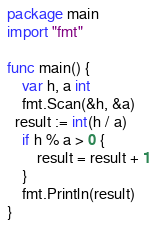<code> <loc_0><loc_0><loc_500><loc_500><_Go_>package main
import "fmt"

func main() {
	var h, a int
  	fmt.Scan(&h, &a)
  result := int(h / a)
  	if h % a > 0 {
  		result = result + 1
  	}
  	fmt.Println(result)
}</code> 